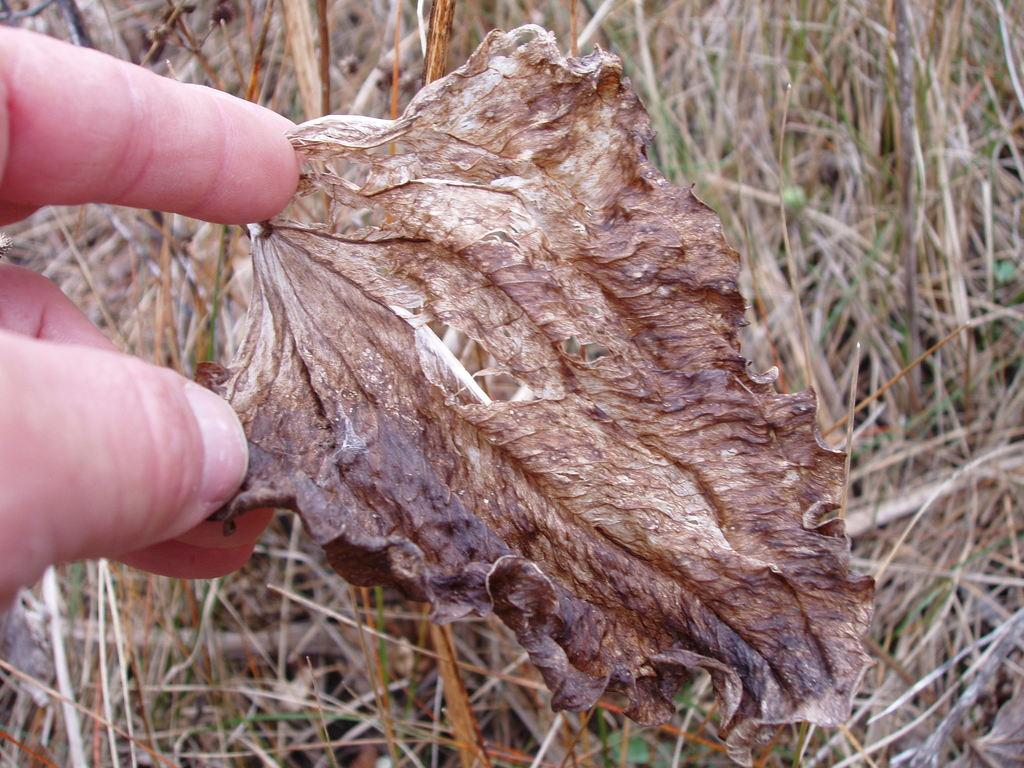What is the person holding in the image? The person is holding a dried leaf in the image. What can be seen in the background of the image? There is grass in the background of the image. How many babies are riding on the donkey in the image? There is no donkey or babies present in the image. 